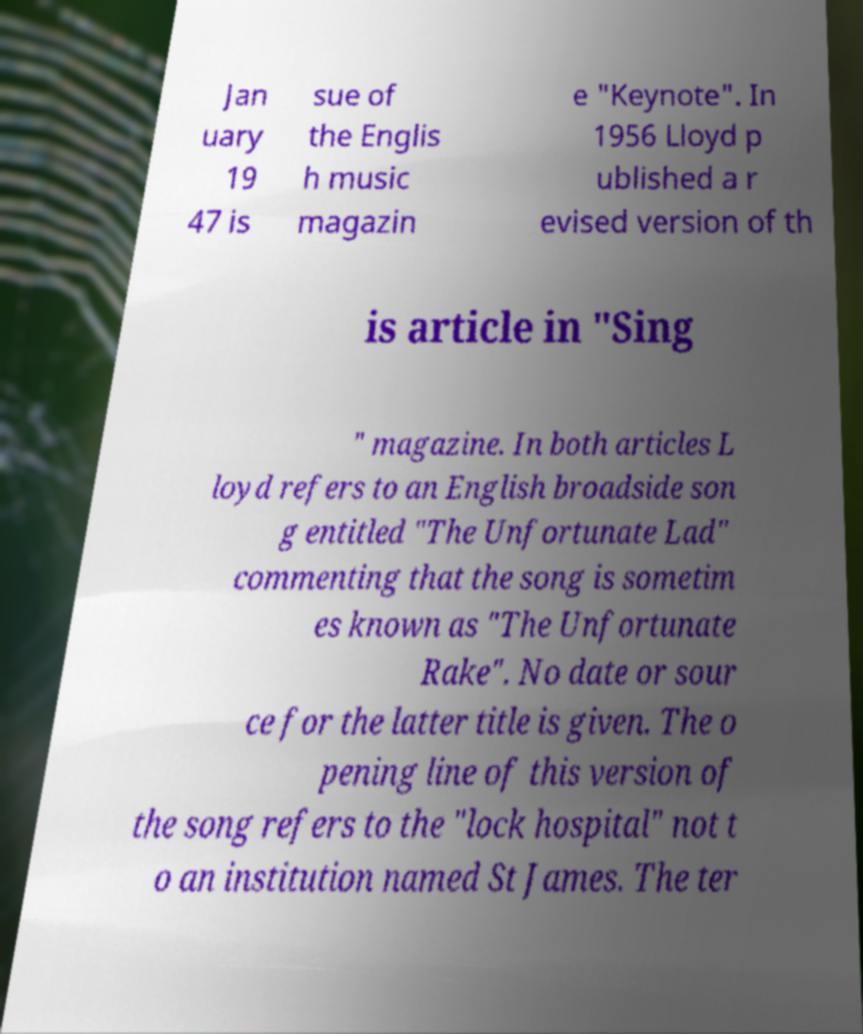Please identify and transcribe the text found in this image. Jan uary 19 47 is sue of the Englis h music magazin e "Keynote". In 1956 Lloyd p ublished a r evised version of th is article in "Sing " magazine. In both articles L loyd refers to an English broadside son g entitled "The Unfortunate Lad" commenting that the song is sometim es known as "The Unfortunate Rake". No date or sour ce for the latter title is given. The o pening line of this version of the song refers to the "lock hospital" not t o an institution named St James. The ter 